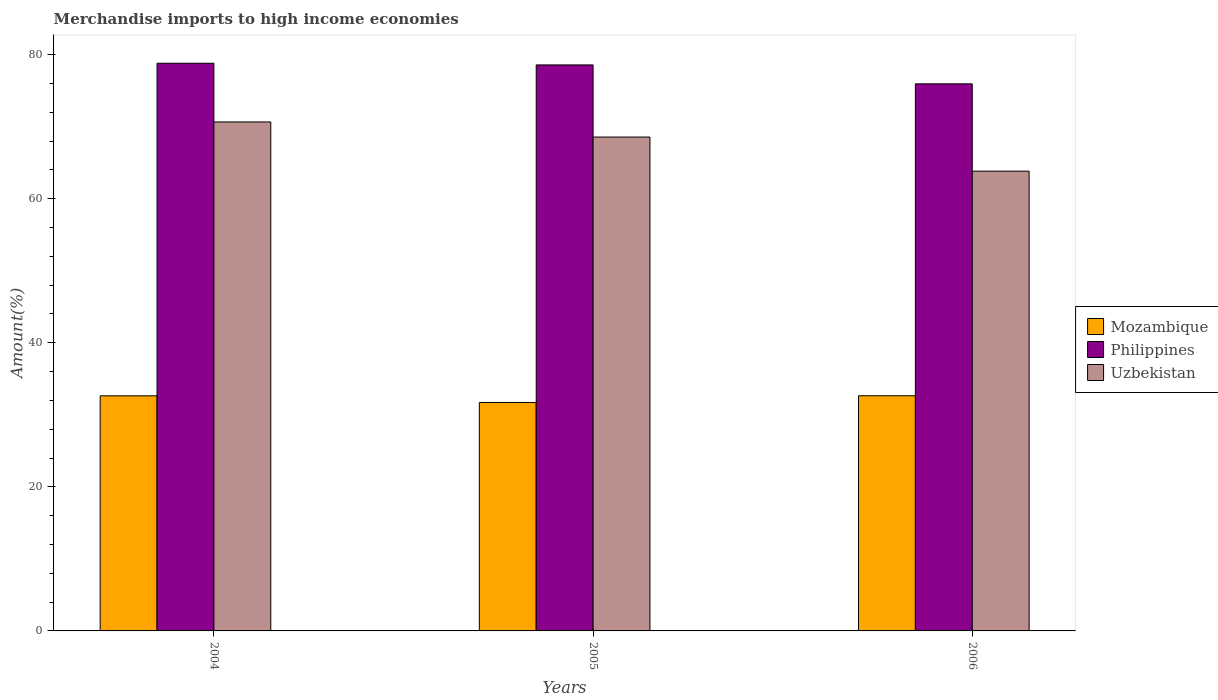How many groups of bars are there?
Your response must be concise. 3. Are the number of bars on each tick of the X-axis equal?
Your answer should be very brief. Yes. How many bars are there on the 1st tick from the right?
Offer a terse response. 3. What is the label of the 3rd group of bars from the left?
Your answer should be very brief. 2006. In how many cases, is the number of bars for a given year not equal to the number of legend labels?
Provide a short and direct response. 0. What is the percentage of amount earned from merchandise imports in Philippines in 2004?
Your response must be concise. 78.81. Across all years, what is the maximum percentage of amount earned from merchandise imports in Uzbekistan?
Offer a very short reply. 70.66. Across all years, what is the minimum percentage of amount earned from merchandise imports in Philippines?
Your response must be concise. 75.95. In which year was the percentage of amount earned from merchandise imports in Mozambique minimum?
Your answer should be compact. 2005. What is the total percentage of amount earned from merchandise imports in Philippines in the graph?
Ensure brevity in your answer.  233.34. What is the difference between the percentage of amount earned from merchandise imports in Uzbekistan in 2004 and that in 2005?
Provide a succinct answer. 2.1. What is the difference between the percentage of amount earned from merchandise imports in Uzbekistan in 2005 and the percentage of amount earned from merchandise imports in Philippines in 2004?
Provide a short and direct response. -10.24. What is the average percentage of amount earned from merchandise imports in Uzbekistan per year?
Offer a very short reply. 67.68. In the year 2005, what is the difference between the percentage of amount earned from merchandise imports in Mozambique and percentage of amount earned from merchandise imports in Uzbekistan?
Your answer should be compact. -36.85. What is the ratio of the percentage of amount earned from merchandise imports in Philippines in 2005 to that in 2006?
Keep it short and to the point. 1.03. Is the difference between the percentage of amount earned from merchandise imports in Mozambique in 2005 and 2006 greater than the difference between the percentage of amount earned from merchandise imports in Uzbekistan in 2005 and 2006?
Offer a terse response. No. What is the difference between the highest and the second highest percentage of amount earned from merchandise imports in Philippines?
Ensure brevity in your answer.  0.23. What is the difference between the highest and the lowest percentage of amount earned from merchandise imports in Mozambique?
Offer a terse response. 0.93. In how many years, is the percentage of amount earned from merchandise imports in Uzbekistan greater than the average percentage of amount earned from merchandise imports in Uzbekistan taken over all years?
Your response must be concise. 2. Is the sum of the percentage of amount earned from merchandise imports in Philippines in 2004 and 2006 greater than the maximum percentage of amount earned from merchandise imports in Mozambique across all years?
Your response must be concise. Yes. What does the 1st bar from the left in 2004 represents?
Give a very brief answer. Mozambique. Is it the case that in every year, the sum of the percentage of amount earned from merchandise imports in Philippines and percentage of amount earned from merchandise imports in Mozambique is greater than the percentage of amount earned from merchandise imports in Uzbekistan?
Provide a succinct answer. Yes. What is the difference between two consecutive major ticks on the Y-axis?
Provide a short and direct response. 20. Are the values on the major ticks of Y-axis written in scientific E-notation?
Ensure brevity in your answer.  No. Where does the legend appear in the graph?
Your answer should be very brief. Center right. What is the title of the graph?
Give a very brief answer. Merchandise imports to high income economies. Does "Hungary" appear as one of the legend labels in the graph?
Provide a succinct answer. No. What is the label or title of the Y-axis?
Provide a succinct answer. Amount(%). What is the Amount(%) of Mozambique in 2004?
Make the answer very short. 32.64. What is the Amount(%) in Philippines in 2004?
Provide a succinct answer. 78.81. What is the Amount(%) in Uzbekistan in 2004?
Offer a very short reply. 70.66. What is the Amount(%) in Mozambique in 2005?
Offer a terse response. 31.71. What is the Amount(%) of Philippines in 2005?
Ensure brevity in your answer.  78.58. What is the Amount(%) in Uzbekistan in 2005?
Make the answer very short. 68.56. What is the Amount(%) in Mozambique in 2006?
Ensure brevity in your answer.  32.65. What is the Amount(%) of Philippines in 2006?
Offer a very short reply. 75.95. What is the Amount(%) in Uzbekistan in 2006?
Offer a terse response. 63.83. Across all years, what is the maximum Amount(%) in Mozambique?
Keep it short and to the point. 32.65. Across all years, what is the maximum Amount(%) of Philippines?
Provide a succinct answer. 78.81. Across all years, what is the maximum Amount(%) in Uzbekistan?
Keep it short and to the point. 70.66. Across all years, what is the minimum Amount(%) of Mozambique?
Keep it short and to the point. 31.71. Across all years, what is the minimum Amount(%) in Philippines?
Give a very brief answer. 75.95. Across all years, what is the minimum Amount(%) of Uzbekistan?
Provide a short and direct response. 63.83. What is the total Amount(%) in Mozambique in the graph?
Give a very brief answer. 97. What is the total Amount(%) of Philippines in the graph?
Make the answer very short. 233.34. What is the total Amount(%) in Uzbekistan in the graph?
Give a very brief answer. 203.05. What is the difference between the Amount(%) in Mozambique in 2004 and that in 2005?
Your answer should be very brief. 0.92. What is the difference between the Amount(%) of Philippines in 2004 and that in 2005?
Make the answer very short. 0.23. What is the difference between the Amount(%) in Uzbekistan in 2004 and that in 2005?
Give a very brief answer. 2.1. What is the difference between the Amount(%) in Mozambique in 2004 and that in 2006?
Give a very brief answer. -0.01. What is the difference between the Amount(%) in Philippines in 2004 and that in 2006?
Your answer should be compact. 2.86. What is the difference between the Amount(%) of Uzbekistan in 2004 and that in 2006?
Your response must be concise. 6.83. What is the difference between the Amount(%) in Mozambique in 2005 and that in 2006?
Your answer should be compact. -0.93. What is the difference between the Amount(%) of Philippines in 2005 and that in 2006?
Provide a succinct answer. 2.63. What is the difference between the Amount(%) of Uzbekistan in 2005 and that in 2006?
Give a very brief answer. 4.73. What is the difference between the Amount(%) in Mozambique in 2004 and the Amount(%) in Philippines in 2005?
Provide a succinct answer. -45.94. What is the difference between the Amount(%) of Mozambique in 2004 and the Amount(%) of Uzbekistan in 2005?
Provide a succinct answer. -35.93. What is the difference between the Amount(%) in Philippines in 2004 and the Amount(%) in Uzbekistan in 2005?
Offer a very short reply. 10.24. What is the difference between the Amount(%) in Mozambique in 2004 and the Amount(%) in Philippines in 2006?
Give a very brief answer. -43.31. What is the difference between the Amount(%) in Mozambique in 2004 and the Amount(%) in Uzbekistan in 2006?
Keep it short and to the point. -31.19. What is the difference between the Amount(%) of Philippines in 2004 and the Amount(%) of Uzbekistan in 2006?
Your answer should be very brief. 14.98. What is the difference between the Amount(%) in Mozambique in 2005 and the Amount(%) in Philippines in 2006?
Your answer should be compact. -44.24. What is the difference between the Amount(%) in Mozambique in 2005 and the Amount(%) in Uzbekistan in 2006?
Your answer should be very brief. -32.12. What is the difference between the Amount(%) of Philippines in 2005 and the Amount(%) of Uzbekistan in 2006?
Keep it short and to the point. 14.75. What is the average Amount(%) of Mozambique per year?
Keep it short and to the point. 32.33. What is the average Amount(%) of Philippines per year?
Give a very brief answer. 77.78. What is the average Amount(%) of Uzbekistan per year?
Provide a succinct answer. 67.68. In the year 2004, what is the difference between the Amount(%) in Mozambique and Amount(%) in Philippines?
Offer a terse response. -46.17. In the year 2004, what is the difference between the Amount(%) in Mozambique and Amount(%) in Uzbekistan?
Give a very brief answer. -38.02. In the year 2004, what is the difference between the Amount(%) of Philippines and Amount(%) of Uzbekistan?
Give a very brief answer. 8.15. In the year 2005, what is the difference between the Amount(%) of Mozambique and Amount(%) of Philippines?
Give a very brief answer. -46.86. In the year 2005, what is the difference between the Amount(%) of Mozambique and Amount(%) of Uzbekistan?
Provide a succinct answer. -36.85. In the year 2005, what is the difference between the Amount(%) of Philippines and Amount(%) of Uzbekistan?
Make the answer very short. 10.02. In the year 2006, what is the difference between the Amount(%) of Mozambique and Amount(%) of Philippines?
Your answer should be very brief. -43.31. In the year 2006, what is the difference between the Amount(%) of Mozambique and Amount(%) of Uzbekistan?
Provide a short and direct response. -31.18. In the year 2006, what is the difference between the Amount(%) in Philippines and Amount(%) in Uzbekistan?
Make the answer very short. 12.12. What is the ratio of the Amount(%) of Mozambique in 2004 to that in 2005?
Your answer should be very brief. 1.03. What is the ratio of the Amount(%) in Uzbekistan in 2004 to that in 2005?
Offer a terse response. 1.03. What is the ratio of the Amount(%) in Philippines in 2004 to that in 2006?
Provide a short and direct response. 1.04. What is the ratio of the Amount(%) of Uzbekistan in 2004 to that in 2006?
Make the answer very short. 1.11. What is the ratio of the Amount(%) of Mozambique in 2005 to that in 2006?
Ensure brevity in your answer.  0.97. What is the ratio of the Amount(%) in Philippines in 2005 to that in 2006?
Give a very brief answer. 1.03. What is the ratio of the Amount(%) in Uzbekistan in 2005 to that in 2006?
Keep it short and to the point. 1.07. What is the difference between the highest and the second highest Amount(%) in Mozambique?
Give a very brief answer. 0.01. What is the difference between the highest and the second highest Amount(%) of Philippines?
Offer a very short reply. 0.23. What is the difference between the highest and the second highest Amount(%) in Uzbekistan?
Make the answer very short. 2.1. What is the difference between the highest and the lowest Amount(%) in Mozambique?
Ensure brevity in your answer.  0.93. What is the difference between the highest and the lowest Amount(%) in Philippines?
Your answer should be very brief. 2.86. What is the difference between the highest and the lowest Amount(%) of Uzbekistan?
Offer a very short reply. 6.83. 